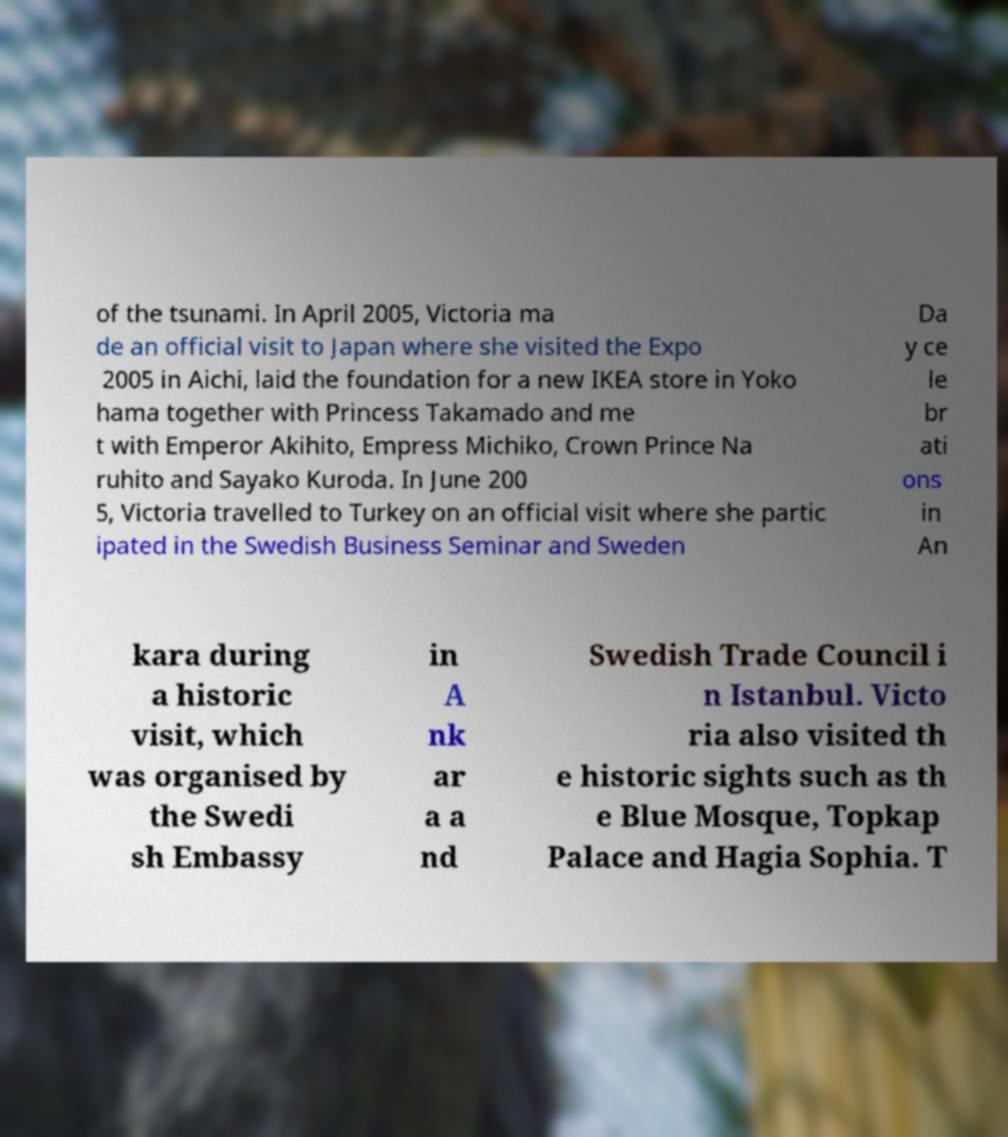What messages or text are displayed in this image? I need them in a readable, typed format. of the tsunami. In April 2005, Victoria ma de an official visit to Japan where she visited the Expo 2005 in Aichi, laid the foundation for a new IKEA store in Yoko hama together with Princess Takamado and me t with Emperor Akihito, Empress Michiko, Crown Prince Na ruhito and Sayako Kuroda. In June 200 5, Victoria travelled to Turkey on an official visit where she partic ipated in the Swedish Business Seminar and Sweden Da y ce le br ati ons in An kara during a historic visit, which was organised by the Swedi sh Embassy in A nk ar a a nd Swedish Trade Council i n Istanbul. Victo ria also visited th e historic sights such as th e Blue Mosque, Topkap Palace and Hagia Sophia. T 